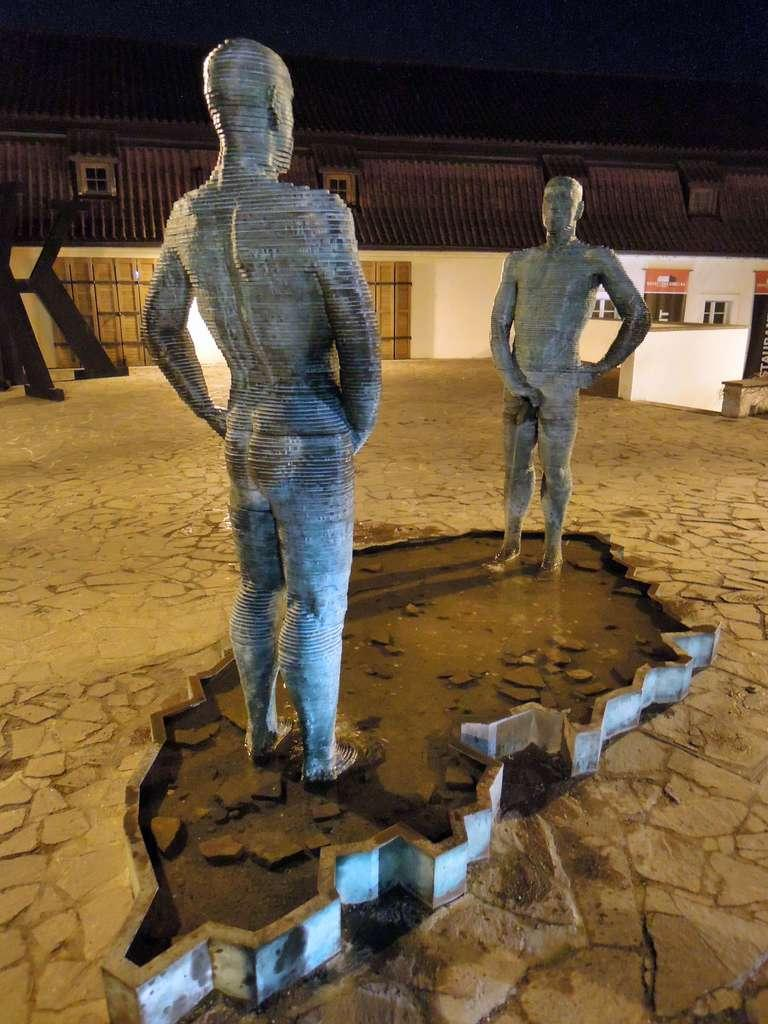What can be seen in the image that represents art or sculpture? There are statues in the image. What type of structure can be seen in the background of the image? There is a building in the background of the image. What architectural feature is visible in the image? There are windows visible in the image. What natural element is present in the image? There is water visible in the image. What type of material is present in the image? There are stones in the image. What type of seating is present in the image? There is a bench in the image. What type of substance is being consumed by the pigs in the image? There are no pigs present in the image, so it is not possible to answer that question. 